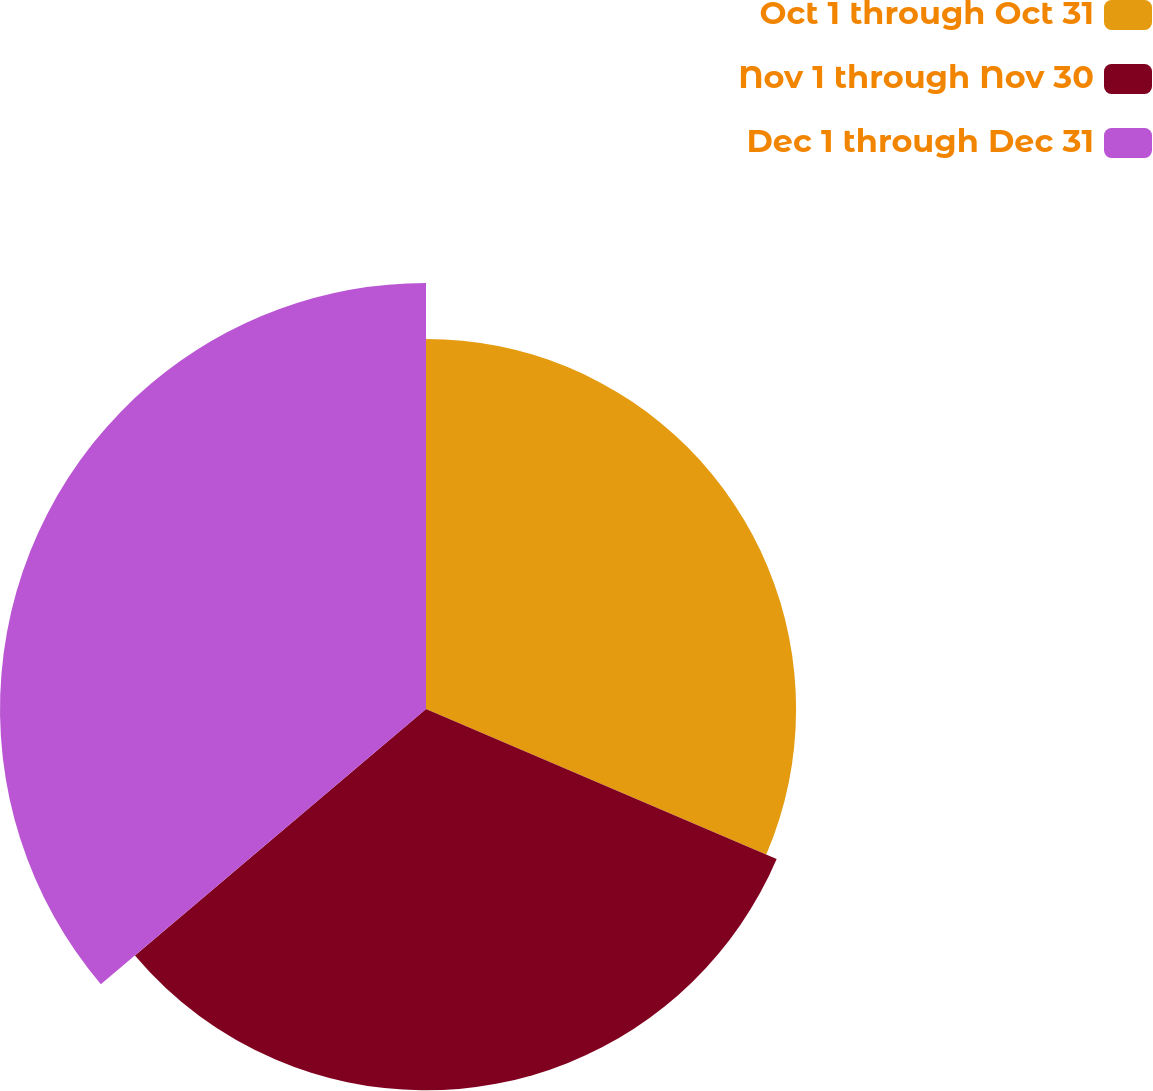Convert chart to OTSL. <chart><loc_0><loc_0><loc_500><loc_500><pie_chart><fcel>Oct 1 through Oct 31<fcel>Nov 1 through Nov 30<fcel>Dec 1 through Dec 31<nl><fcel>31.43%<fcel>32.39%<fcel>36.18%<nl></chart> 